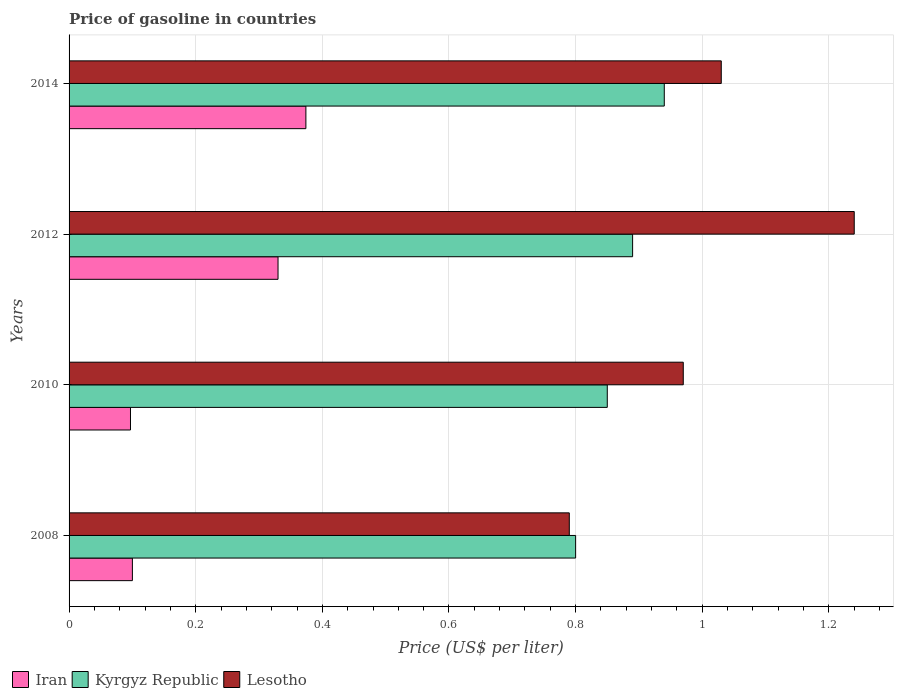How many different coloured bars are there?
Make the answer very short. 3. Across all years, what is the maximum price of gasoline in Kyrgyz Republic?
Provide a succinct answer. 0.94. Across all years, what is the minimum price of gasoline in Iran?
Keep it short and to the point. 0.1. What is the total price of gasoline in Kyrgyz Republic in the graph?
Provide a short and direct response. 3.48. What is the difference between the price of gasoline in Kyrgyz Republic in 2008 and that in 2012?
Your response must be concise. -0.09. What is the difference between the price of gasoline in Kyrgyz Republic in 2010 and the price of gasoline in Iran in 2008?
Offer a terse response. 0.75. What is the average price of gasoline in Iran per year?
Your answer should be very brief. 0.23. In the year 2012, what is the difference between the price of gasoline in Lesotho and price of gasoline in Kyrgyz Republic?
Provide a succinct answer. 0.35. In how many years, is the price of gasoline in Lesotho greater than 0.36 US$?
Your answer should be very brief. 4. What is the ratio of the price of gasoline in Lesotho in 2008 to that in 2010?
Offer a terse response. 0.81. Is the price of gasoline in Lesotho in 2010 less than that in 2012?
Ensure brevity in your answer.  Yes. What is the difference between the highest and the second highest price of gasoline in Lesotho?
Provide a succinct answer. 0.21. What is the difference between the highest and the lowest price of gasoline in Lesotho?
Make the answer very short. 0.45. Is the sum of the price of gasoline in Kyrgyz Republic in 2008 and 2014 greater than the maximum price of gasoline in Lesotho across all years?
Keep it short and to the point. Yes. What does the 2nd bar from the top in 2014 represents?
Your answer should be compact. Kyrgyz Republic. What does the 3rd bar from the bottom in 2014 represents?
Make the answer very short. Lesotho. Is it the case that in every year, the sum of the price of gasoline in Iran and price of gasoline in Kyrgyz Republic is greater than the price of gasoline in Lesotho?
Keep it short and to the point. No. How many bars are there?
Your answer should be compact. 12. Are the values on the major ticks of X-axis written in scientific E-notation?
Provide a succinct answer. No. Does the graph contain any zero values?
Give a very brief answer. No. Does the graph contain grids?
Your answer should be compact. Yes. How are the legend labels stacked?
Offer a terse response. Horizontal. What is the title of the graph?
Offer a very short reply. Price of gasoline in countries. Does "Kyrgyz Republic" appear as one of the legend labels in the graph?
Offer a very short reply. Yes. What is the label or title of the X-axis?
Your response must be concise. Price (US$ per liter). What is the label or title of the Y-axis?
Provide a short and direct response. Years. What is the Price (US$ per liter) in Kyrgyz Republic in 2008?
Ensure brevity in your answer.  0.8. What is the Price (US$ per liter) in Lesotho in 2008?
Offer a very short reply. 0.79. What is the Price (US$ per liter) of Iran in 2010?
Provide a short and direct response. 0.1. What is the Price (US$ per liter) of Kyrgyz Republic in 2010?
Offer a very short reply. 0.85. What is the Price (US$ per liter) in Iran in 2012?
Offer a terse response. 0.33. What is the Price (US$ per liter) of Kyrgyz Republic in 2012?
Provide a short and direct response. 0.89. What is the Price (US$ per liter) in Lesotho in 2012?
Offer a very short reply. 1.24. What is the Price (US$ per liter) of Iran in 2014?
Keep it short and to the point. 0.37. What is the Price (US$ per liter) in Kyrgyz Republic in 2014?
Your response must be concise. 0.94. What is the Price (US$ per liter) of Lesotho in 2014?
Make the answer very short. 1.03. Across all years, what is the maximum Price (US$ per liter) of Iran?
Your answer should be compact. 0.37. Across all years, what is the maximum Price (US$ per liter) in Lesotho?
Provide a short and direct response. 1.24. Across all years, what is the minimum Price (US$ per liter) in Iran?
Offer a terse response. 0.1. Across all years, what is the minimum Price (US$ per liter) of Kyrgyz Republic?
Your answer should be compact. 0.8. Across all years, what is the minimum Price (US$ per liter) in Lesotho?
Your answer should be compact. 0.79. What is the total Price (US$ per liter) of Iran in the graph?
Offer a terse response. 0.9. What is the total Price (US$ per liter) of Kyrgyz Republic in the graph?
Provide a succinct answer. 3.48. What is the total Price (US$ per liter) in Lesotho in the graph?
Keep it short and to the point. 4.03. What is the difference between the Price (US$ per liter) in Iran in 2008 and that in 2010?
Make the answer very short. 0. What is the difference between the Price (US$ per liter) in Lesotho in 2008 and that in 2010?
Ensure brevity in your answer.  -0.18. What is the difference between the Price (US$ per liter) of Iran in 2008 and that in 2012?
Your answer should be compact. -0.23. What is the difference between the Price (US$ per liter) of Kyrgyz Republic in 2008 and that in 2012?
Offer a very short reply. -0.09. What is the difference between the Price (US$ per liter) in Lesotho in 2008 and that in 2012?
Ensure brevity in your answer.  -0.45. What is the difference between the Price (US$ per liter) in Iran in 2008 and that in 2014?
Offer a very short reply. -0.27. What is the difference between the Price (US$ per liter) of Kyrgyz Republic in 2008 and that in 2014?
Keep it short and to the point. -0.14. What is the difference between the Price (US$ per liter) in Lesotho in 2008 and that in 2014?
Give a very brief answer. -0.24. What is the difference between the Price (US$ per liter) in Iran in 2010 and that in 2012?
Give a very brief answer. -0.23. What is the difference between the Price (US$ per liter) of Kyrgyz Republic in 2010 and that in 2012?
Offer a terse response. -0.04. What is the difference between the Price (US$ per liter) in Lesotho in 2010 and that in 2012?
Your answer should be compact. -0.27. What is the difference between the Price (US$ per liter) of Iran in 2010 and that in 2014?
Provide a succinct answer. -0.28. What is the difference between the Price (US$ per liter) of Kyrgyz Republic in 2010 and that in 2014?
Ensure brevity in your answer.  -0.09. What is the difference between the Price (US$ per liter) in Lesotho in 2010 and that in 2014?
Your answer should be compact. -0.06. What is the difference between the Price (US$ per liter) of Iran in 2012 and that in 2014?
Your answer should be compact. -0.04. What is the difference between the Price (US$ per liter) of Kyrgyz Republic in 2012 and that in 2014?
Provide a succinct answer. -0.05. What is the difference between the Price (US$ per liter) in Lesotho in 2012 and that in 2014?
Your response must be concise. 0.21. What is the difference between the Price (US$ per liter) of Iran in 2008 and the Price (US$ per liter) of Kyrgyz Republic in 2010?
Your response must be concise. -0.75. What is the difference between the Price (US$ per liter) of Iran in 2008 and the Price (US$ per liter) of Lesotho in 2010?
Keep it short and to the point. -0.87. What is the difference between the Price (US$ per liter) in Kyrgyz Republic in 2008 and the Price (US$ per liter) in Lesotho in 2010?
Give a very brief answer. -0.17. What is the difference between the Price (US$ per liter) in Iran in 2008 and the Price (US$ per liter) in Kyrgyz Republic in 2012?
Ensure brevity in your answer.  -0.79. What is the difference between the Price (US$ per liter) in Iran in 2008 and the Price (US$ per liter) in Lesotho in 2012?
Make the answer very short. -1.14. What is the difference between the Price (US$ per liter) in Kyrgyz Republic in 2008 and the Price (US$ per liter) in Lesotho in 2012?
Keep it short and to the point. -0.44. What is the difference between the Price (US$ per liter) in Iran in 2008 and the Price (US$ per liter) in Kyrgyz Republic in 2014?
Offer a terse response. -0.84. What is the difference between the Price (US$ per liter) in Iran in 2008 and the Price (US$ per liter) in Lesotho in 2014?
Ensure brevity in your answer.  -0.93. What is the difference between the Price (US$ per liter) in Kyrgyz Republic in 2008 and the Price (US$ per liter) in Lesotho in 2014?
Offer a very short reply. -0.23. What is the difference between the Price (US$ per liter) of Iran in 2010 and the Price (US$ per liter) of Kyrgyz Republic in 2012?
Keep it short and to the point. -0.79. What is the difference between the Price (US$ per liter) of Iran in 2010 and the Price (US$ per liter) of Lesotho in 2012?
Make the answer very short. -1.14. What is the difference between the Price (US$ per liter) of Kyrgyz Republic in 2010 and the Price (US$ per liter) of Lesotho in 2012?
Keep it short and to the point. -0.39. What is the difference between the Price (US$ per liter) in Iran in 2010 and the Price (US$ per liter) in Kyrgyz Republic in 2014?
Give a very brief answer. -0.84. What is the difference between the Price (US$ per liter) of Iran in 2010 and the Price (US$ per liter) of Lesotho in 2014?
Provide a succinct answer. -0.93. What is the difference between the Price (US$ per liter) in Kyrgyz Republic in 2010 and the Price (US$ per liter) in Lesotho in 2014?
Your response must be concise. -0.18. What is the difference between the Price (US$ per liter) of Iran in 2012 and the Price (US$ per liter) of Kyrgyz Republic in 2014?
Provide a succinct answer. -0.61. What is the difference between the Price (US$ per liter) of Kyrgyz Republic in 2012 and the Price (US$ per liter) of Lesotho in 2014?
Your answer should be compact. -0.14. What is the average Price (US$ per liter) in Iran per year?
Give a very brief answer. 0.23. What is the average Price (US$ per liter) of Kyrgyz Republic per year?
Your response must be concise. 0.87. What is the average Price (US$ per liter) in Lesotho per year?
Your answer should be very brief. 1.01. In the year 2008, what is the difference between the Price (US$ per liter) of Iran and Price (US$ per liter) of Lesotho?
Provide a short and direct response. -0.69. In the year 2010, what is the difference between the Price (US$ per liter) in Iran and Price (US$ per liter) in Kyrgyz Republic?
Your response must be concise. -0.75. In the year 2010, what is the difference between the Price (US$ per liter) of Iran and Price (US$ per liter) of Lesotho?
Your answer should be very brief. -0.87. In the year 2010, what is the difference between the Price (US$ per liter) of Kyrgyz Republic and Price (US$ per liter) of Lesotho?
Your response must be concise. -0.12. In the year 2012, what is the difference between the Price (US$ per liter) of Iran and Price (US$ per liter) of Kyrgyz Republic?
Ensure brevity in your answer.  -0.56. In the year 2012, what is the difference between the Price (US$ per liter) of Iran and Price (US$ per liter) of Lesotho?
Provide a short and direct response. -0.91. In the year 2012, what is the difference between the Price (US$ per liter) in Kyrgyz Republic and Price (US$ per liter) in Lesotho?
Give a very brief answer. -0.35. In the year 2014, what is the difference between the Price (US$ per liter) in Iran and Price (US$ per liter) in Kyrgyz Republic?
Your response must be concise. -0.57. In the year 2014, what is the difference between the Price (US$ per liter) in Iran and Price (US$ per liter) in Lesotho?
Give a very brief answer. -0.66. In the year 2014, what is the difference between the Price (US$ per liter) of Kyrgyz Republic and Price (US$ per liter) of Lesotho?
Your answer should be very brief. -0.09. What is the ratio of the Price (US$ per liter) in Iran in 2008 to that in 2010?
Make the answer very short. 1.03. What is the ratio of the Price (US$ per liter) of Kyrgyz Republic in 2008 to that in 2010?
Your answer should be very brief. 0.94. What is the ratio of the Price (US$ per liter) in Lesotho in 2008 to that in 2010?
Ensure brevity in your answer.  0.81. What is the ratio of the Price (US$ per liter) of Iran in 2008 to that in 2012?
Your answer should be compact. 0.3. What is the ratio of the Price (US$ per liter) in Kyrgyz Republic in 2008 to that in 2012?
Provide a short and direct response. 0.9. What is the ratio of the Price (US$ per liter) in Lesotho in 2008 to that in 2012?
Your response must be concise. 0.64. What is the ratio of the Price (US$ per liter) in Iran in 2008 to that in 2014?
Give a very brief answer. 0.27. What is the ratio of the Price (US$ per liter) of Kyrgyz Republic in 2008 to that in 2014?
Provide a short and direct response. 0.85. What is the ratio of the Price (US$ per liter) of Lesotho in 2008 to that in 2014?
Offer a very short reply. 0.77. What is the ratio of the Price (US$ per liter) in Iran in 2010 to that in 2012?
Make the answer very short. 0.29. What is the ratio of the Price (US$ per liter) in Kyrgyz Republic in 2010 to that in 2012?
Your answer should be very brief. 0.96. What is the ratio of the Price (US$ per liter) in Lesotho in 2010 to that in 2012?
Your answer should be compact. 0.78. What is the ratio of the Price (US$ per liter) in Iran in 2010 to that in 2014?
Keep it short and to the point. 0.26. What is the ratio of the Price (US$ per liter) in Kyrgyz Republic in 2010 to that in 2014?
Your answer should be compact. 0.9. What is the ratio of the Price (US$ per liter) in Lesotho in 2010 to that in 2014?
Make the answer very short. 0.94. What is the ratio of the Price (US$ per liter) of Iran in 2012 to that in 2014?
Ensure brevity in your answer.  0.88. What is the ratio of the Price (US$ per liter) of Kyrgyz Republic in 2012 to that in 2014?
Keep it short and to the point. 0.95. What is the ratio of the Price (US$ per liter) of Lesotho in 2012 to that in 2014?
Give a very brief answer. 1.2. What is the difference between the highest and the second highest Price (US$ per liter) in Iran?
Your response must be concise. 0.04. What is the difference between the highest and the second highest Price (US$ per liter) of Kyrgyz Republic?
Give a very brief answer. 0.05. What is the difference between the highest and the second highest Price (US$ per liter) of Lesotho?
Ensure brevity in your answer.  0.21. What is the difference between the highest and the lowest Price (US$ per liter) in Iran?
Your answer should be very brief. 0.28. What is the difference between the highest and the lowest Price (US$ per liter) in Kyrgyz Republic?
Provide a short and direct response. 0.14. What is the difference between the highest and the lowest Price (US$ per liter) of Lesotho?
Give a very brief answer. 0.45. 